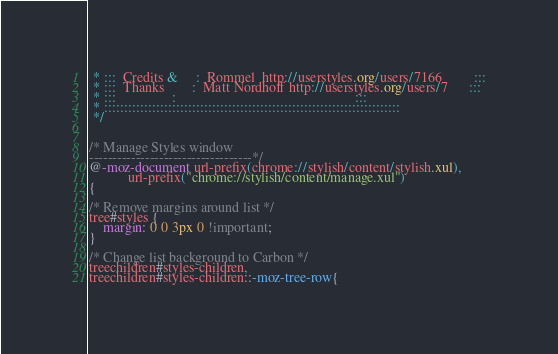<code> <loc_0><loc_0><loc_500><loc_500><_CSS_> * :::  Credits &     :  Rommel  http://userstyles.org/users/7166         :::
 * :::  Thanks        :  Matt Nordhoff http://userstyles.org/users/7      :::
 * :::                :                                                   :::
 * :::::::::::::::::::::::::::::::::::::::::::::::::::::::::::::::::::::::::: 
 */


/* Manage Styles window
-----------------------------------*/
@-moz-document url-prefix(chrome://stylish/content/stylish.xul), 
		   url-prefix("chrome://stylish/content/manage.xul") 
{ 

/* Remove margins around list */
tree#styles {
	margin: 0 0 3px 0 !important; 
}

/* Change list background to Carbon */
treechildren#styles-children,
treechildren#styles-children::-moz-tree-row{</code> 